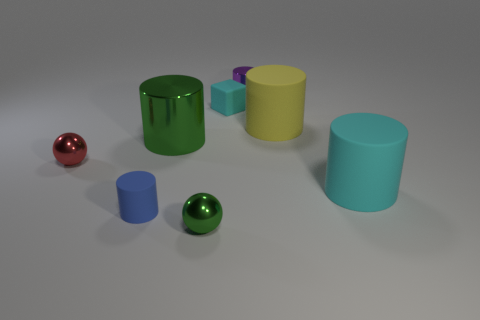There is a ball to the left of the green shiny cylinder; how many tiny cylinders are to the left of it?
Ensure brevity in your answer.  0. Is the number of things in front of the cyan matte cylinder greater than the number of small cyan rubber things?
Ensure brevity in your answer.  Yes. How big is the matte thing that is to the right of the small purple shiny cylinder and in front of the big yellow thing?
Offer a terse response. Large. There is a object that is both to the right of the purple cylinder and in front of the small red shiny object; what is its shape?
Provide a short and direct response. Cylinder. There is a cyan matte object left of the metal object that is behind the cube; is there a big yellow object in front of it?
Your answer should be compact. Yes. How many objects are either cyan matte objects that are behind the large yellow matte object or objects in front of the small matte cube?
Give a very brief answer. 7. Are the cyan thing that is on the left side of the large cyan cylinder and the yellow cylinder made of the same material?
Ensure brevity in your answer.  Yes. The cylinder that is both in front of the big green cylinder and left of the yellow rubber object is made of what material?
Keep it short and to the point. Rubber. There is a large cylinder on the left side of the small shiny thing that is right of the small green object; what is its color?
Keep it short and to the point. Green. What material is the small blue object that is the same shape as the large cyan matte object?
Keep it short and to the point. Rubber. 